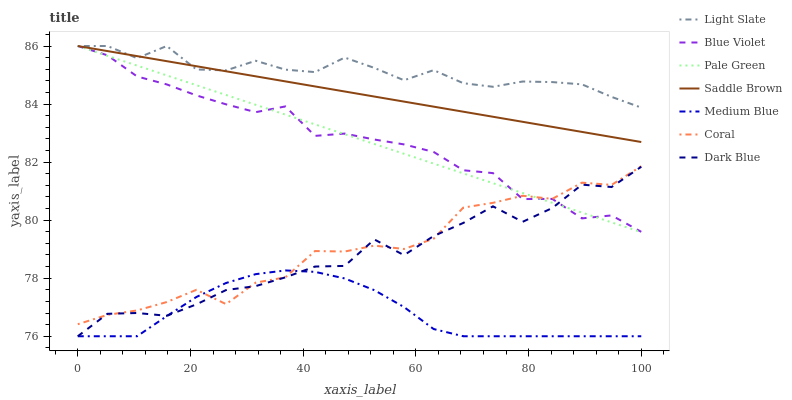Does Coral have the minimum area under the curve?
Answer yes or no. No. Does Coral have the maximum area under the curve?
Answer yes or no. No. Is Coral the smoothest?
Answer yes or no. No. Is Coral the roughest?
Answer yes or no. No. Does Coral have the lowest value?
Answer yes or no. No. Does Coral have the highest value?
Answer yes or no. No. Is Dark Blue less than Saddle Brown?
Answer yes or no. Yes. Is Light Slate greater than Medium Blue?
Answer yes or no. Yes. Does Dark Blue intersect Saddle Brown?
Answer yes or no. No. 